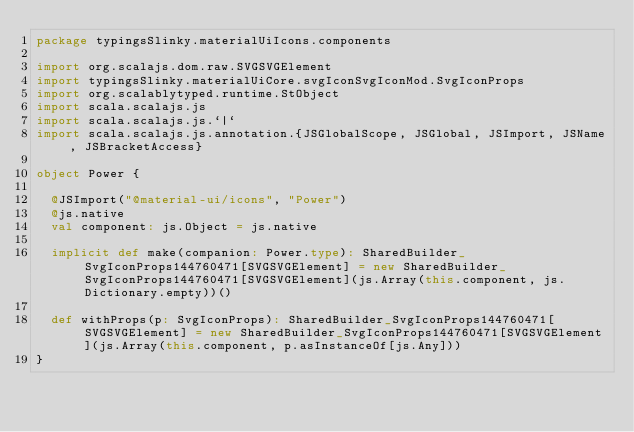<code> <loc_0><loc_0><loc_500><loc_500><_Scala_>package typingsSlinky.materialUiIcons.components

import org.scalajs.dom.raw.SVGSVGElement
import typingsSlinky.materialUiCore.svgIconSvgIconMod.SvgIconProps
import org.scalablytyped.runtime.StObject
import scala.scalajs.js
import scala.scalajs.js.`|`
import scala.scalajs.js.annotation.{JSGlobalScope, JSGlobal, JSImport, JSName, JSBracketAccess}

object Power {
  
  @JSImport("@material-ui/icons", "Power")
  @js.native
  val component: js.Object = js.native
  
  implicit def make(companion: Power.type): SharedBuilder_SvgIconProps144760471[SVGSVGElement] = new SharedBuilder_SvgIconProps144760471[SVGSVGElement](js.Array(this.component, js.Dictionary.empty))()
  
  def withProps(p: SvgIconProps): SharedBuilder_SvgIconProps144760471[SVGSVGElement] = new SharedBuilder_SvgIconProps144760471[SVGSVGElement](js.Array(this.component, p.asInstanceOf[js.Any]))
}
</code> 